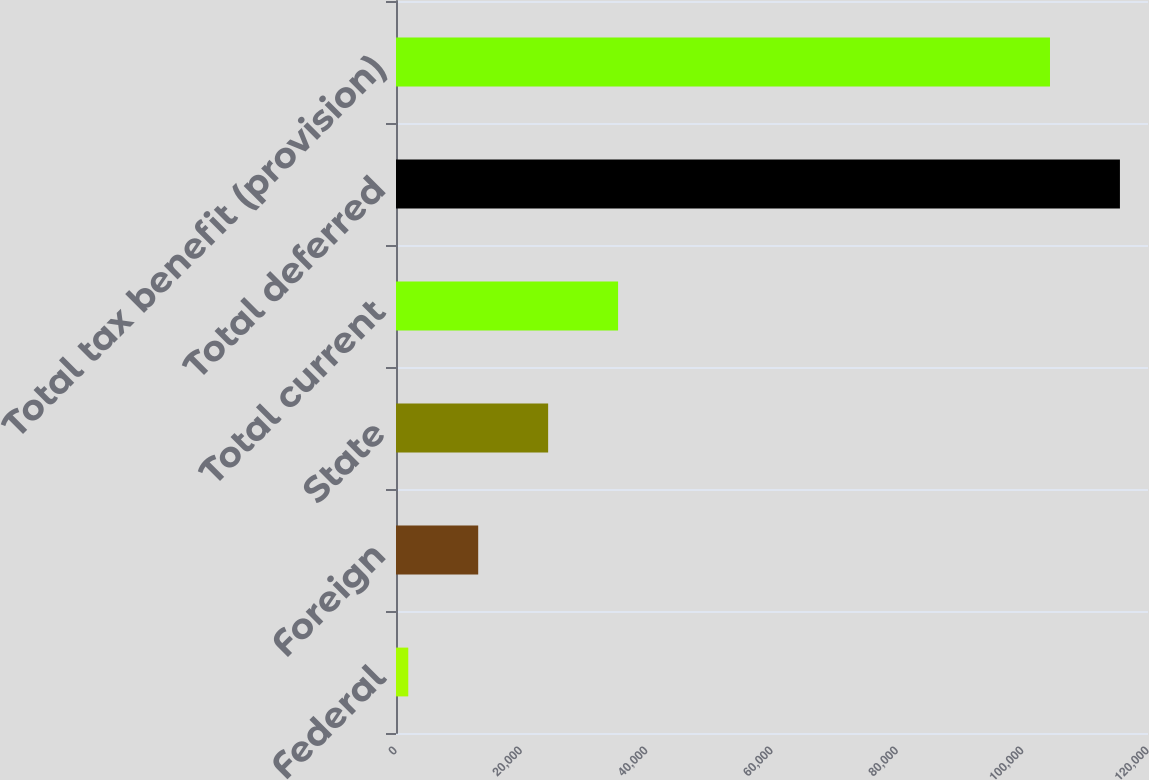<chart> <loc_0><loc_0><loc_500><loc_500><bar_chart><fcel>Federal<fcel>Foreign<fcel>State<fcel>Total current<fcel>Total deferred<fcel>Total tax benefit (provision)<nl><fcel>1958<fcel>13117.9<fcel>24277.8<fcel>35437.7<fcel>115521<fcel>104361<nl></chart> 